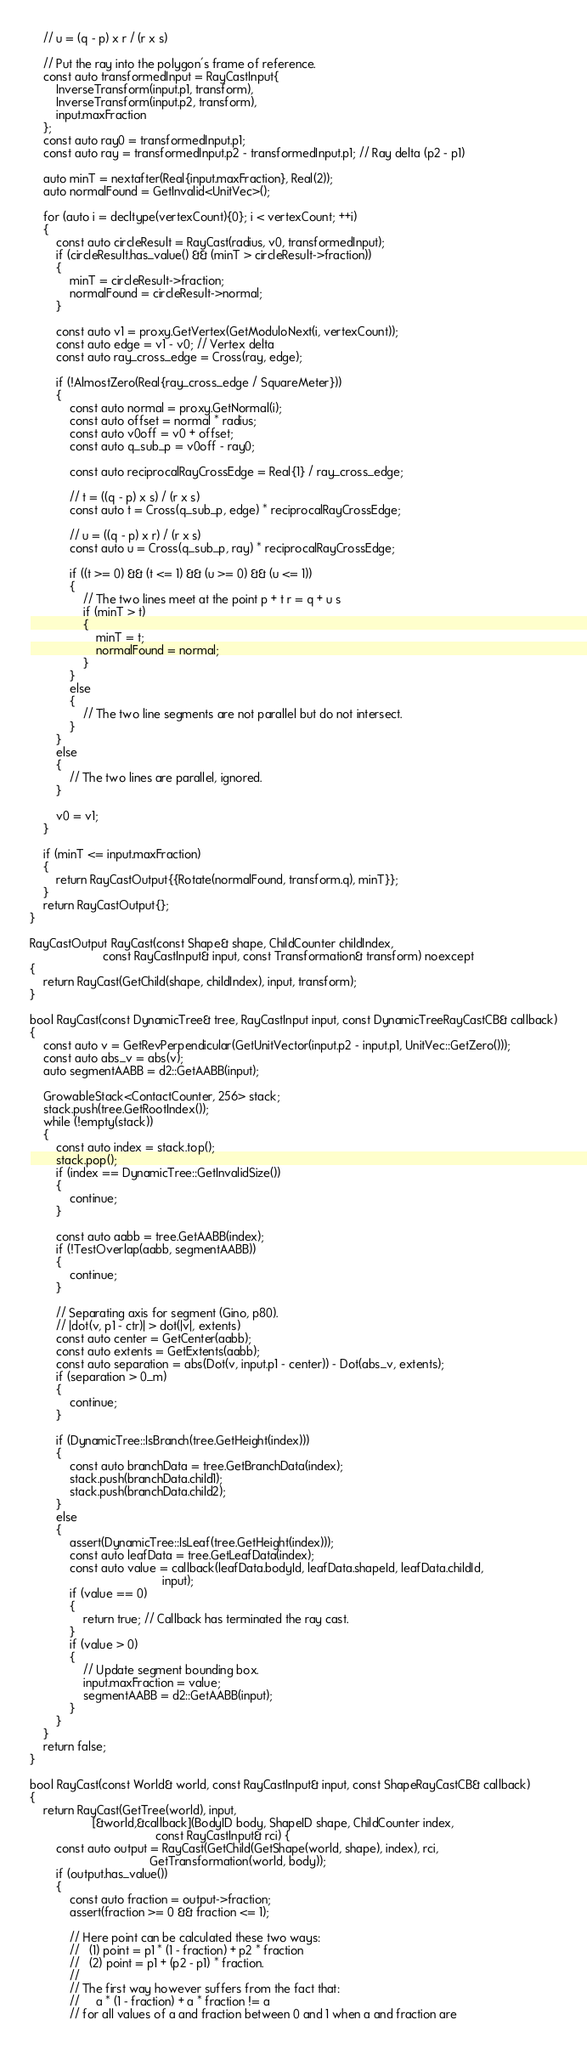<code> <loc_0><loc_0><loc_500><loc_500><_C++_>    // u = (q - p) x r / (r x s)

    // Put the ray into the polygon's frame of reference.
    const auto transformedInput = RayCastInput{
        InverseTransform(input.p1, transform),
        InverseTransform(input.p2, transform),
        input.maxFraction
    };
    const auto ray0 = transformedInput.p1;
    const auto ray = transformedInput.p2 - transformedInput.p1; // Ray delta (p2 - p1)
    
    auto minT = nextafter(Real{input.maxFraction}, Real(2));
    auto normalFound = GetInvalid<UnitVec>();
    
    for (auto i = decltype(vertexCount){0}; i < vertexCount; ++i)
    {
        const auto circleResult = RayCast(radius, v0, transformedInput);
        if (circleResult.has_value() && (minT > circleResult->fraction))
        {
            minT = circleResult->fraction;
            normalFound = circleResult->normal;
        }

        const auto v1 = proxy.GetVertex(GetModuloNext(i, vertexCount));
        const auto edge = v1 - v0; // Vertex delta
        const auto ray_cross_edge = Cross(ray, edge);
        
        if (!AlmostZero(Real{ray_cross_edge / SquareMeter}))
        {
            const auto normal = proxy.GetNormal(i);
            const auto offset = normal * radius;
            const auto v0off = v0 + offset;
            const auto q_sub_p = v0off - ray0;
            
            const auto reciprocalRayCrossEdge = Real{1} / ray_cross_edge;

            // t = ((q - p) x s) / (r x s)
            const auto t = Cross(q_sub_p, edge) * reciprocalRayCrossEdge;
            
            // u = ((q - p) x r) / (r x s)
            const auto u = Cross(q_sub_p, ray) * reciprocalRayCrossEdge;

            if ((t >= 0) && (t <= 1) && (u >= 0) && (u <= 1))
            {
                // The two lines meet at the point p + t r = q + u s
                if (minT > t)
                {
                    minT = t;
                    normalFound = normal;
                }
            }
            else
            {
                // The two line segments are not parallel but do not intersect.
            }
        }
        else
        {
            // The two lines are parallel, ignored.
        }
        
        v0 = v1;
    }
    
    if (minT <= input.maxFraction)
    {
        return RayCastOutput{{Rotate(normalFound, transform.q), minT}};
    }
    return RayCastOutput{};
}

RayCastOutput RayCast(const Shape& shape, ChildCounter childIndex,
                      const RayCastInput& input, const Transformation& transform) noexcept
{
    return RayCast(GetChild(shape, childIndex), input, transform);
}

bool RayCast(const DynamicTree& tree, RayCastInput input, const DynamicTreeRayCastCB& callback)
{    
    const auto v = GetRevPerpendicular(GetUnitVector(input.p2 - input.p1, UnitVec::GetZero()));
    const auto abs_v = abs(v);
    auto segmentAABB = d2::GetAABB(input);
    
    GrowableStack<ContactCounter, 256> stack;
    stack.push(tree.GetRootIndex());
    while (!empty(stack))
    {
        const auto index = stack.top();
        stack.pop();
        if (index == DynamicTree::GetInvalidSize())
        {
            continue;
        }
        
        const auto aabb = tree.GetAABB(index);
        if (!TestOverlap(aabb, segmentAABB))
        {
            continue;
        }
        
        // Separating axis for segment (Gino, p80).
        // |dot(v, p1 - ctr)| > dot(|v|, extents)
        const auto center = GetCenter(aabb);
        const auto extents = GetExtents(aabb);
        const auto separation = abs(Dot(v, input.p1 - center)) - Dot(abs_v, extents);
        if (separation > 0_m)
        {
            continue;
        }
        
        if (DynamicTree::IsBranch(tree.GetHeight(index)))
        {
            const auto branchData = tree.GetBranchData(index);
            stack.push(branchData.child1);
            stack.push(branchData.child2);
        }
        else
        {
            assert(DynamicTree::IsLeaf(tree.GetHeight(index)));
            const auto leafData = tree.GetLeafData(index);
            const auto value = callback(leafData.bodyId, leafData.shapeId, leafData.childId,
                                        input);
            if (value == 0)
            {
                return true; // Callback has terminated the ray cast.
            }
            if (value > 0)
            {
                // Update segment bounding box.
                input.maxFraction = value;
                segmentAABB = d2::GetAABB(input);
            }
        }
    }
    return false;
}

bool RayCast(const World& world, const RayCastInput& input, const ShapeRayCastCB& callback)
{
    return RayCast(GetTree(world), input,
                   [&world,&callback](BodyID body, ShapeID shape, ChildCounter index,
                                      const RayCastInput& rci) {
        const auto output = RayCast(GetChild(GetShape(world, shape), index), rci,
                                    GetTransformation(world, body));
        if (output.has_value())
        {
            const auto fraction = output->fraction;
            assert(fraction >= 0 && fraction <= 1);
            
            // Here point can be calculated these two ways:
            //   (1) point = p1 * (1 - fraction) + p2 * fraction
            //   (2) point = p1 + (p2 - p1) * fraction.
            //
            // The first way however suffers from the fact that:
            //     a * (1 - fraction) + a * fraction != a
            // for all values of a and fraction between 0 and 1 when a and fraction are</code> 